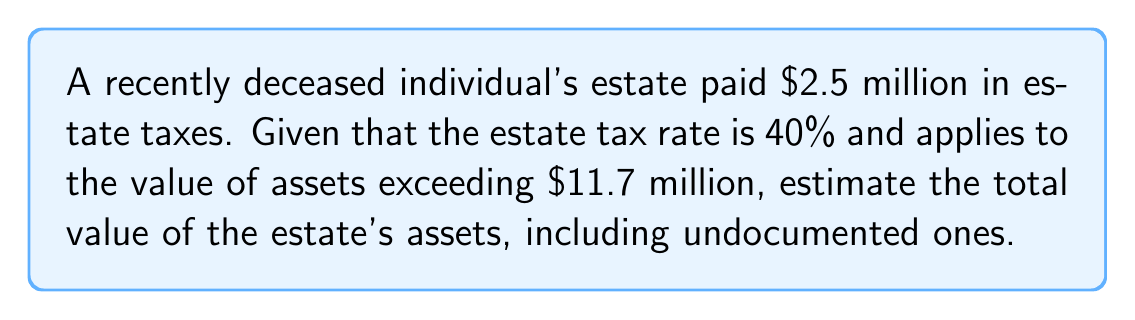Can you answer this question? Let's approach this step-by-step:

1) Let $x$ be the total value of the estate's assets.

2) The taxable portion of the estate is $(x - 11.7)$ million dollars, as the first $11.7 million is exempt from estate tax.

3) The estate tax paid is 40% of the taxable portion. We can express this as an equation:

   $0.40(x - 11.7) = 2.5$

4) Let's solve this equation for $x$:

   $x - 11.7 = 2.5 / 0.40 = 6.25$
   
   $x = 6.25 + 11.7 = 17.95$

5) Therefore, the total value of the estate's assets is $17.95 million.

6) To verify:
   Taxable portion: $17.95 - 11.7 = 6.25$ million
   Tax paid: $6.25 * 0.40 = 2.5$ million, which matches the given information.

This method allows us to estimate the total value of the estate, including any undocumented assets, based on the known estate tax payment.
Answer: $17.95 million 